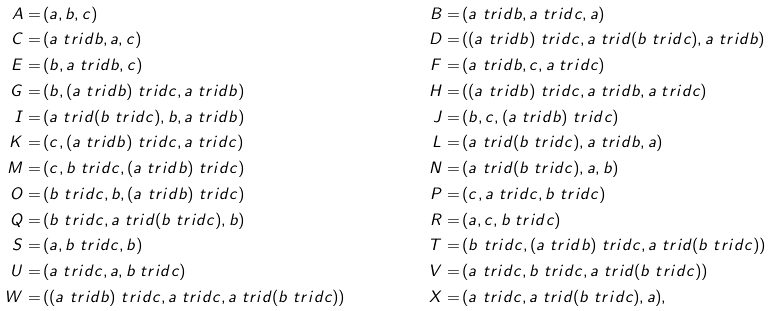<formula> <loc_0><loc_0><loc_500><loc_500>A = & \, ( a , b , c ) & B = & \, ( a \ t r i d b , a \ t r i d c , a ) \\ C = & \, ( a \ t r i d b , a , c ) & D = & \, ( ( a \ t r i d b ) \ t r i d c , a \ t r i d ( b \ t r i d c ) , a \ t r i d b ) \\ E = & \, ( b , a \ t r i d b , c ) & F = & \, ( a \ t r i d b , c , a \ t r i d c ) \\ G = & \, ( b , ( a \ t r i d b ) \ t r i d c , a \ t r i d b ) & H = & \, ( ( a \ t r i d b ) \ t r i d c , a \ t r i d b , a \ t r i d c ) \\ I = & \, ( a \ t r i d ( b \ t r i d c ) , b , a \ t r i d b ) & J = & \, ( b , c , ( a \ t r i d b ) \ t r i d c ) \\ K = & \, ( c , ( a \ t r i d b ) \ t r i d c , a \ t r i d c ) & L = & \, ( a \ t r i d ( b \ t r i d c ) , a \ t r i d b , a ) \\ M = & \, ( c , b \ t r i d c , ( a \ t r i d b ) \ t r i d c ) & N = & \, ( a \ t r i d ( b \ t r i d c ) , a , b ) \\ O = & \, ( b \ t r i d c , b , ( a \ t r i d b ) \ t r i d c ) & P = & \, ( c , a \ t r i d c , b \ t r i d c ) \\ Q = & \, ( b \ t r i d c , a \ t r i d ( b \ t r i d c ) , b ) & R = & \, ( a , c , b \ t r i d c ) \\ S = & \, ( a , b \ t r i d c , b ) & T = & \, ( b \ t r i d c , ( a \ t r i d b ) \ t r i d c , a \ t r i d ( b \ t r i d c ) ) \\ U = & \, ( a \ t r i d c , a , b \ t r i d c ) & V = & \, ( a \ t r i d c , b \ t r i d c , a \ t r i d ( b \ t r i d c ) ) \\ W = & \, ( ( a \ t r i d b ) \ t r i d c , a \ t r i d c , a \ t r i d ( b \ t r i d c ) ) & X = & \, ( a \ t r i d c , a \ t r i d ( b \ t r i d c ) , a ) ,</formula> 